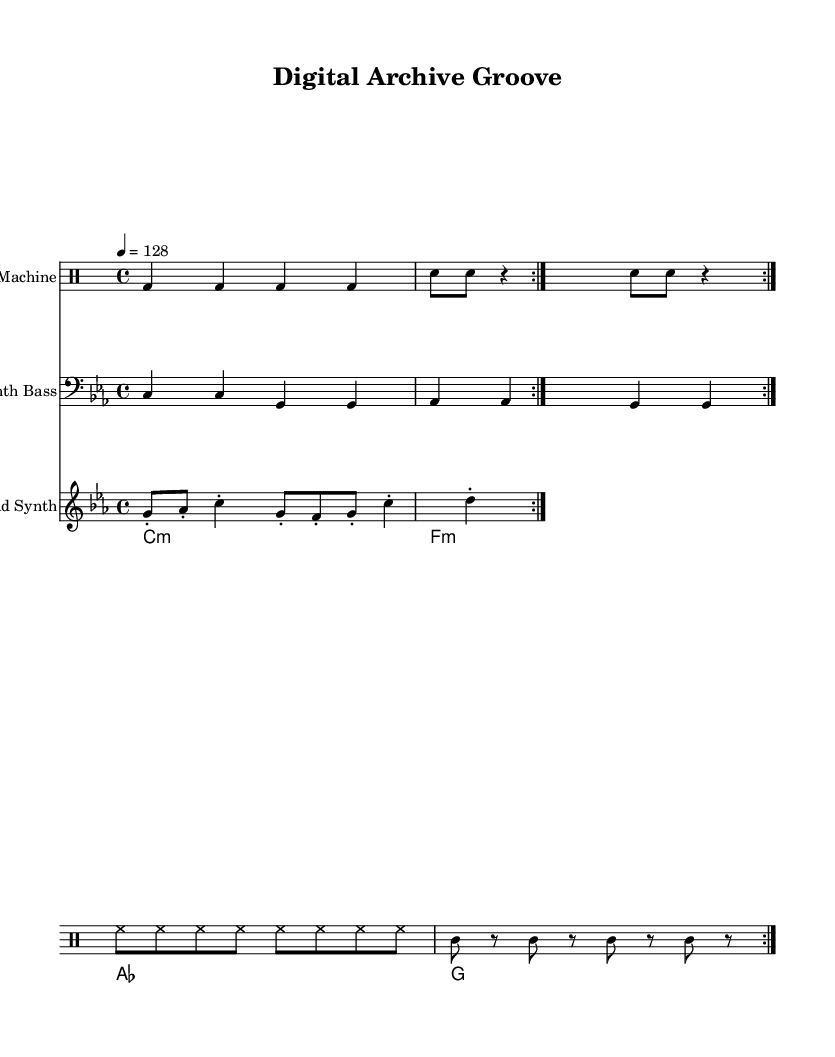What is the key signature of this music? The key signature is C minor, indicated by three flats in the key signature. This can be confirmed by looking at the score where the key is specified in the global settings.
Answer: C minor What is the time signature of the piece? The time signature is 4/4, which means there are four beats in each measure and the quarter note receives one beat. This is noted in the global settings at the beginning of the code.
Answer: 4/4 What is the tempo marking indicated in the score? The tempo marking shows a speed of 128 beats per minute, which is commonly used for electronic dance music. This is specified in the global settings where "4 = 128" indicates the beats per minute.
Answer: 128 How many times is the drum pattern repeated? The drum pattern is repeated 2 times as indicated by the "repeat volta 2" command in the drum machine section of the score. This means the entire pattern will play two times in succession.
Answer: 2 What type of chord progression is used in the pad synth? The chord progression in the pad synth is a minor progression involving the chords C minor, F minor, A flat major, and G major, which is typical in house music for creating a moody atmosphere. This can be confirmed by examining the chord mode section in the score.
Answer: C minor, F minor, A flat, G major Which instrument holds the lead melody? The lead melody is played by the lead synth, which is labeled in the score. The notes and rhythm patterns specifically arranged for the lead synth indicate it carries the melodic content.
Answer: Lead synth 